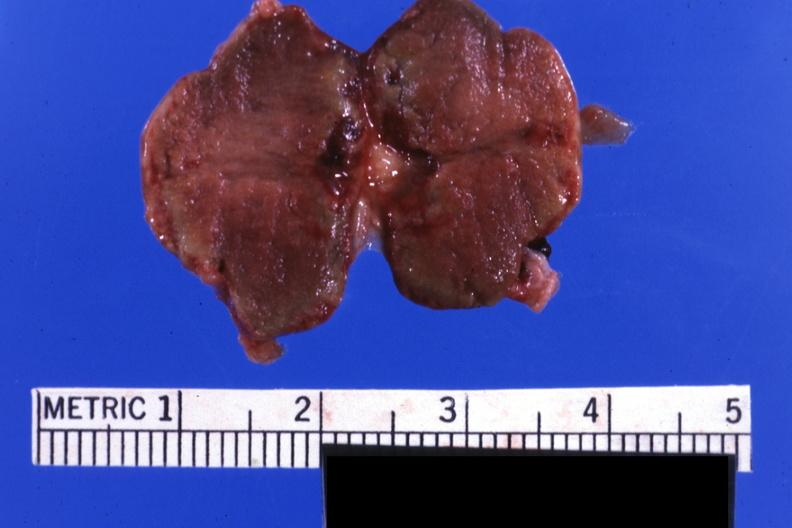s endocrine present?
Answer the question using a single word or phrase. Yes 